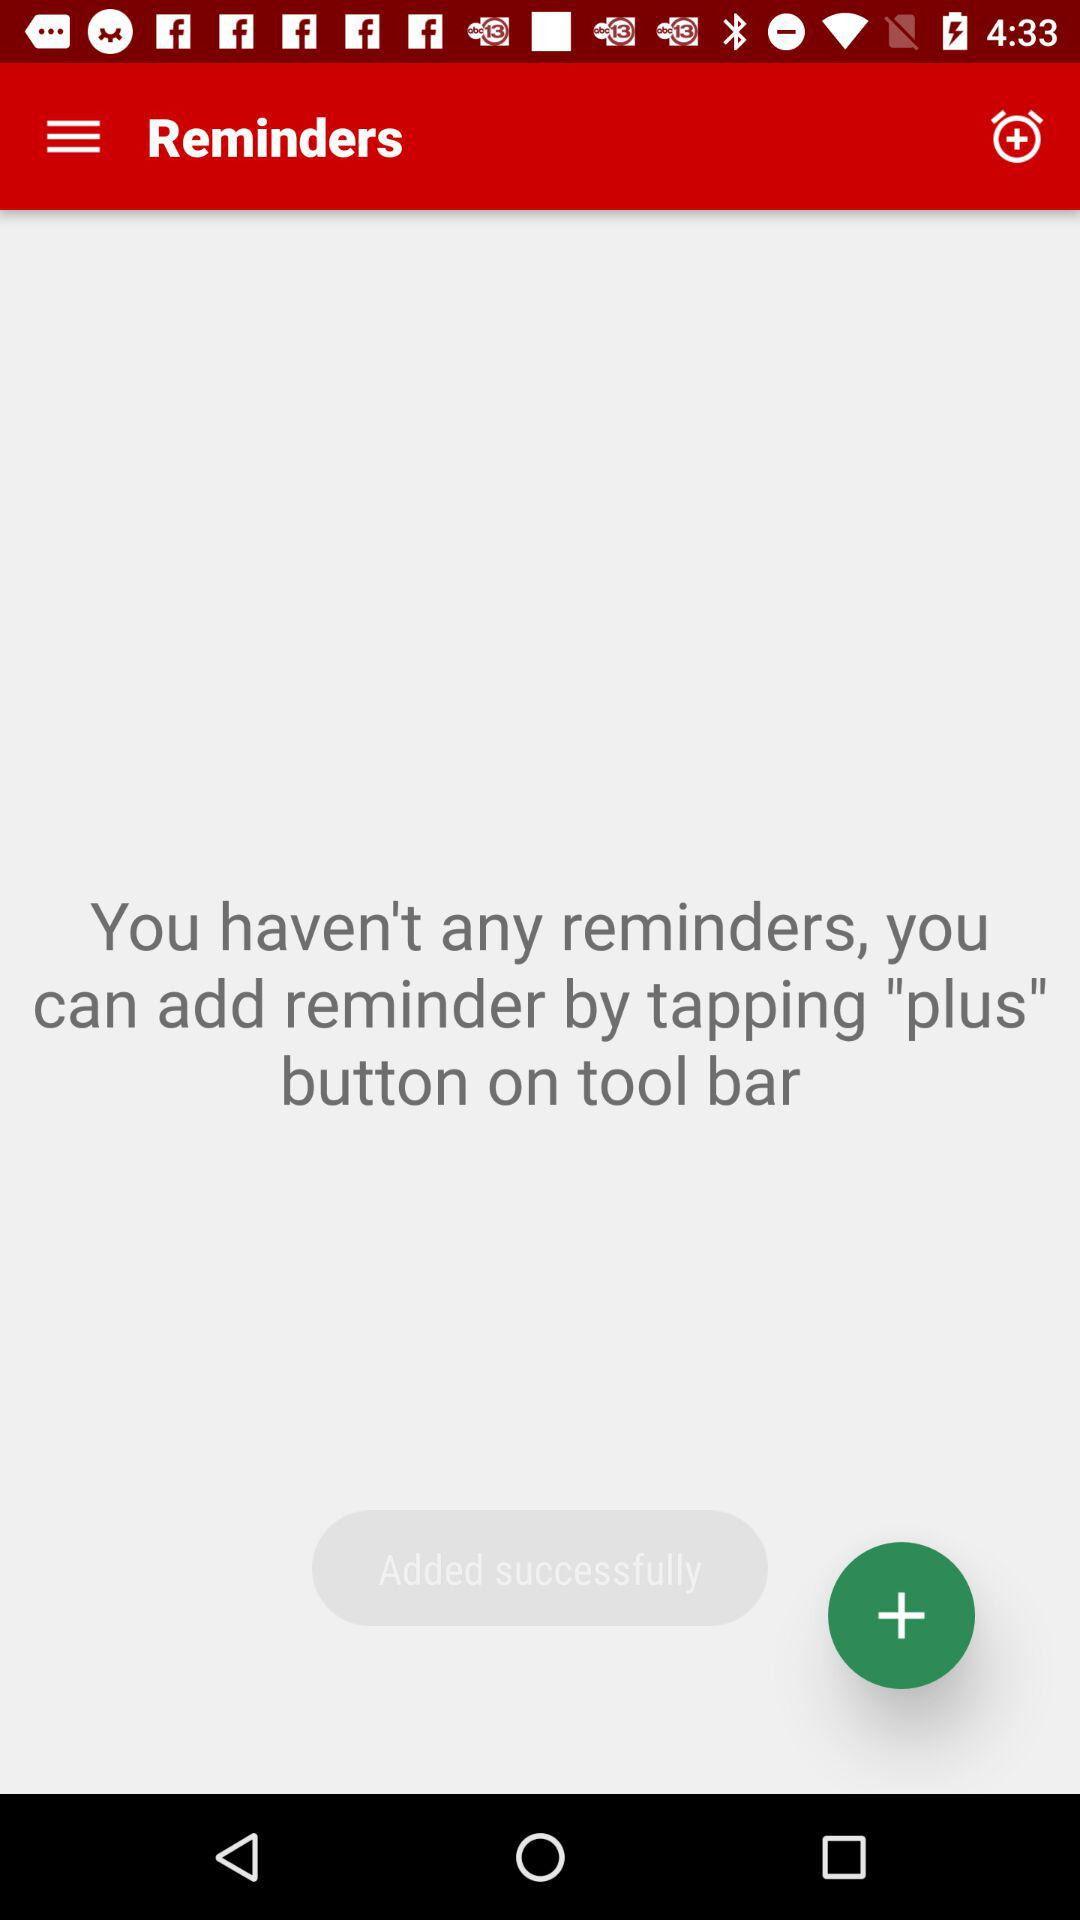How many reminders are there?
Answer the question using a single word or phrase. 0 